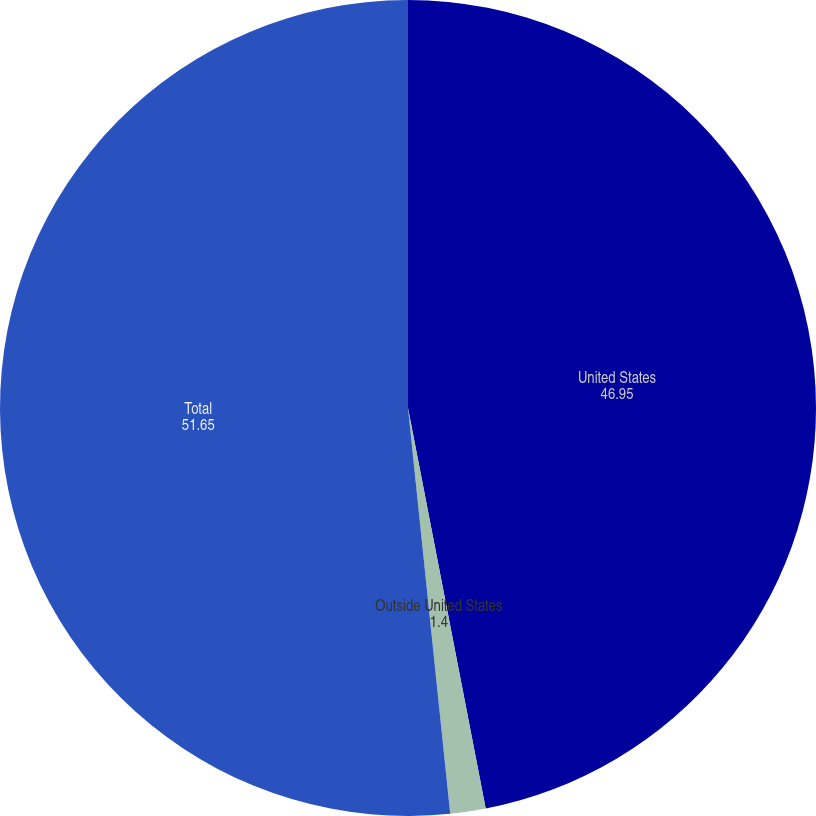Convert chart. <chart><loc_0><loc_0><loc_500><loc_500><pie_chart><fcel>United States<fcel>Outside United States<fcel>Total<nl><fcel>46.95%<fcel>1.4%<fcel>51.65%<nl></chart> 